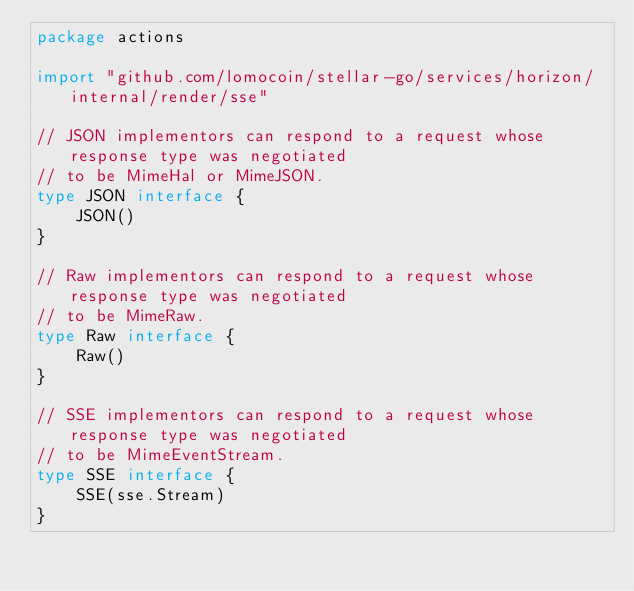<code> <loc_0><loc_0><loc_500><loc_500><_Go_>package actions

import "github.com/lomocoin/stellar-go/services/horizon/internal/render/sse"

// JSON implementors can respond to a request whose response type was negotiated
// to be MimeHal or MimeJSON.
type JSON interface {
	JSON()
}

// Raw implementors can respond to a request whose response type was negotiated
// to be MimeRaw.
type Raw interface {
	Raw()
}

// SSE implementors can respond to a request whose response type was negotiated
// to be MimeEventStream.
type SSE interface {
	SSE(sse.Stream)
}
</code> 